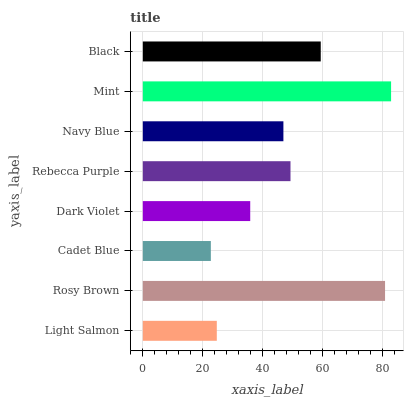Is Cadet Blue the minimum?
Answer yes or no. Yes. Is Mint the maximum?
Answer yes or no. Yes. Is Rosy Brown the minimum?
Answer yes or no. No. Is Rosy Brown the maximum?
Answer yes or no. No. Is Rosy Brown greater than Light Salmon?
Answer yes or no. Yes. Is Light Salmon less than Rosy Brown?
Answer yes or no. Yes. Is Light Salmon greater than Rosy Brown?
Answer yes or no. No. Is Rosy Brown less than Light Salmon?
Answer yes or no. No. Is Rebecca Purple the high median?
Answer yes or no. Yes. Is Navy Blue the low median?
Answer yes or no. Yes. Is Dark Violet the high median?
Answer yes or no. No. Is Rebecca Purple the low median?
Answer yes or no. No. 